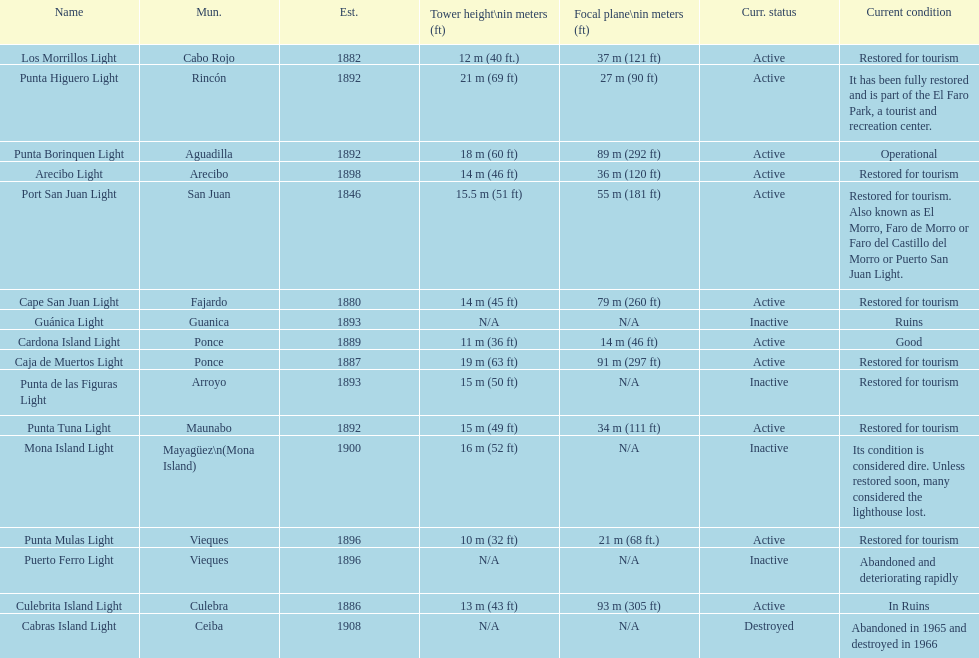Which municipality was the first to be established? San Juan. 